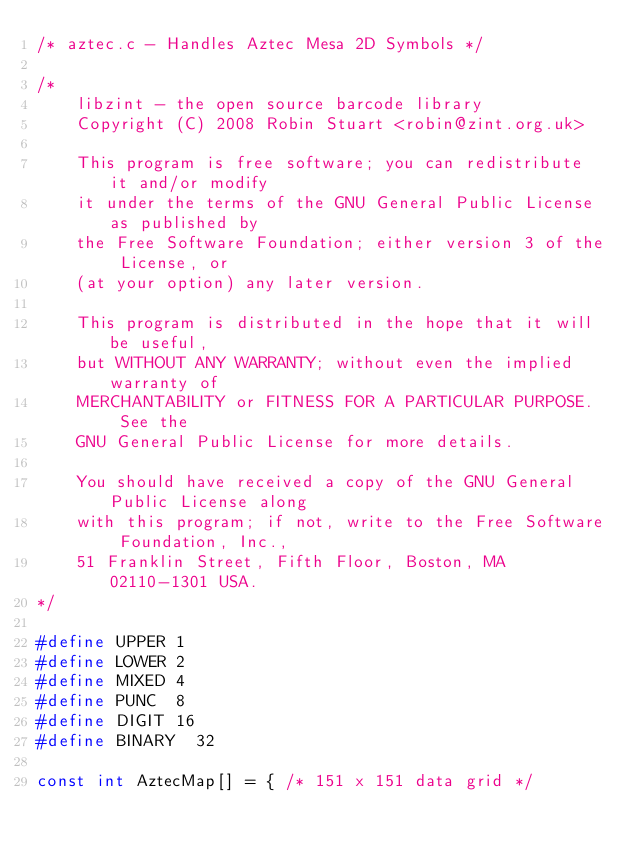<code> <loc_0><loc_0><loc_500><loc_500><_C_>/* aztec.c - Handles Aztec Mesa 2D Symbols */

/*
    libzint - the open source barcode library
    Copyright (C) 2008 Robin Stuart <robin@zint.org.uk>

    This program is free software; you can redistribute it and/or modify
    it under the terms of the GNU General Public License as published by
    the Free Software Foundation; either version 3 of the License, or
    (at your option) any later version.

    This program is distributed in the hope that it will be useful,
    but WITHOUT ANY WARRANTY; without even the implied warranty of
    MERCHANTABILITY or FITNESS FOR A PARTICULAR PURPOSE.  See the
    GNU General Public License for more details.

    You should have received a copy of the GNU General Public License along
    with this program; if not, write to the Free Software Foundation, Inc.,
    51 Franklin Street, Fifth Floor, Boston, MA 02110-1301 USA.
*/

#define UPPER	1
#define LOWER	2
#define MIXED	4
#define PUNC	8
#define DIGIT	16
#define BINARY	32

const int AztecMap[] = { /* 151 x 151 data grid */</code> 